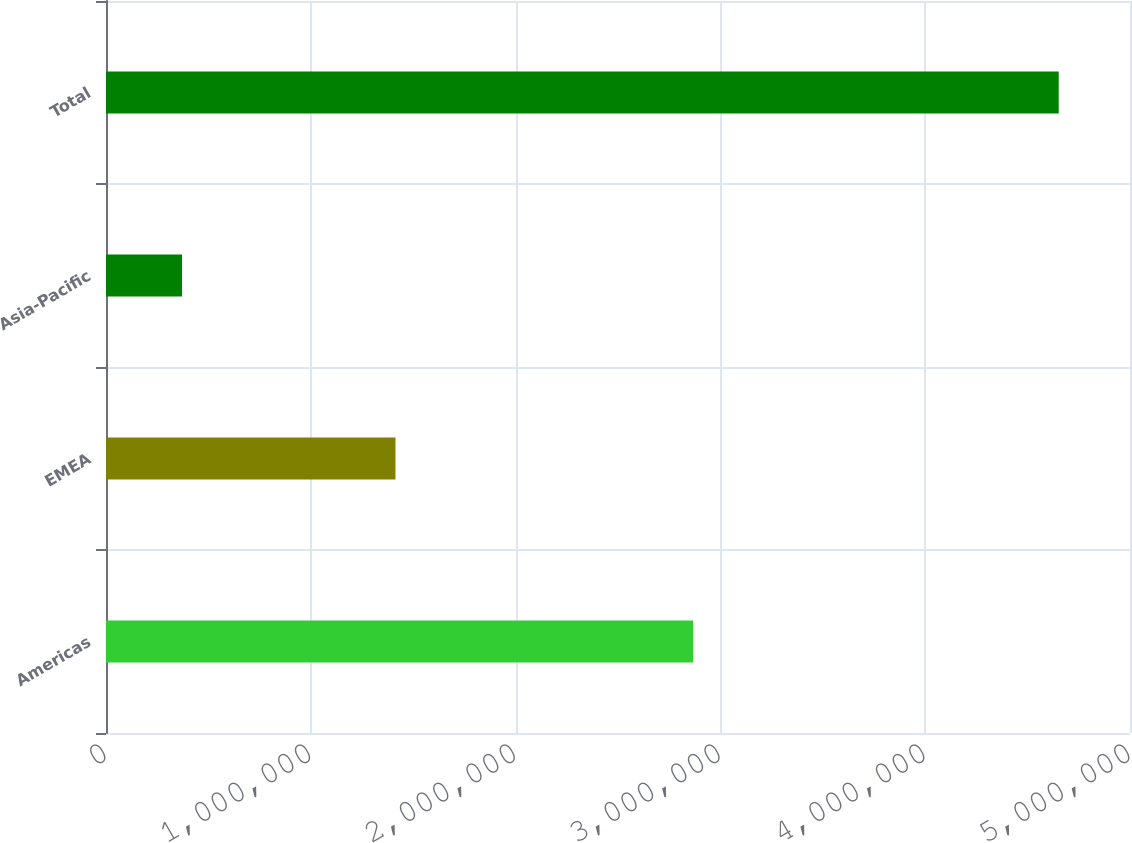Convert chart to OTSL. <chart><loc_0><loc_0><loc_500><loc_500><bar_chart><fcel>Americas<fcel>EMEA<fcel>Asia-Pacific<fcel>Total<nl><fcel>2.86735e+06<fcel>1.41344e+06<fcel>371101<fcel>4.6519e+06<nl></chart> 